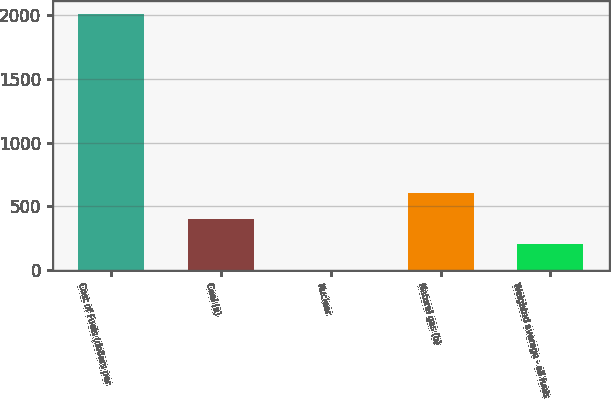Convert chart. <chart><loc_0><loc_0><loc_500><loc_500><bar_chart><fcel>Cost of Fuels (dollars per<fcel>Coal (a)<fcel>Nuclear<fcel>Natural gas (b)<fcel>Weighted average - all fuels<nl><fcel>2012<fcel>403.16<fcel>0.96<fcel>604.26<fcel>202.06<nl></chart> 